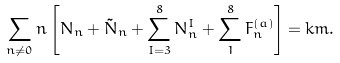<formula> <loc_0><loc_0><loc_500><loc_500>\sum _ { n \neq 0 } n \left [ N _ { n } + \tilde { N } _ { n } + \sum _ { I = 3 } ^ { 8 } N _ { n } ^ { I } + \sum _ { 1 } ^ { 8 } F _ { n } ^ { ( a ) } \right ] = k m .</formula> 